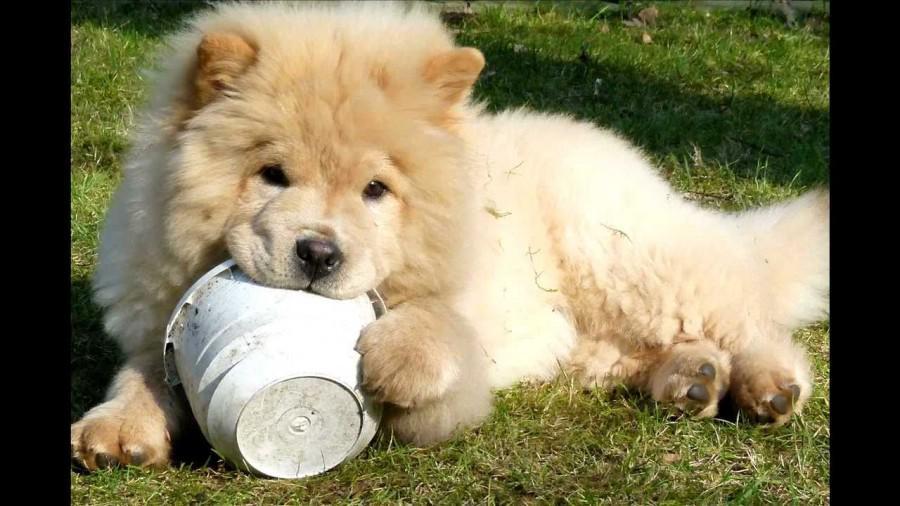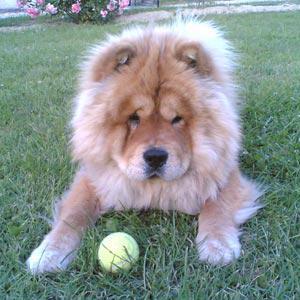The first image is the image on the left, the second image is the image on the right. Given the left and right images, does the statement "One dog has his left front paw off the ground." hold true? Answer yes or no. Yes. The first image is the image on the left, the second image is the image on the right. Evaluate the accuracy of this statement regarding the images: "Only one dog is not in the grass.". Is it true? Answer yes or no. No. 